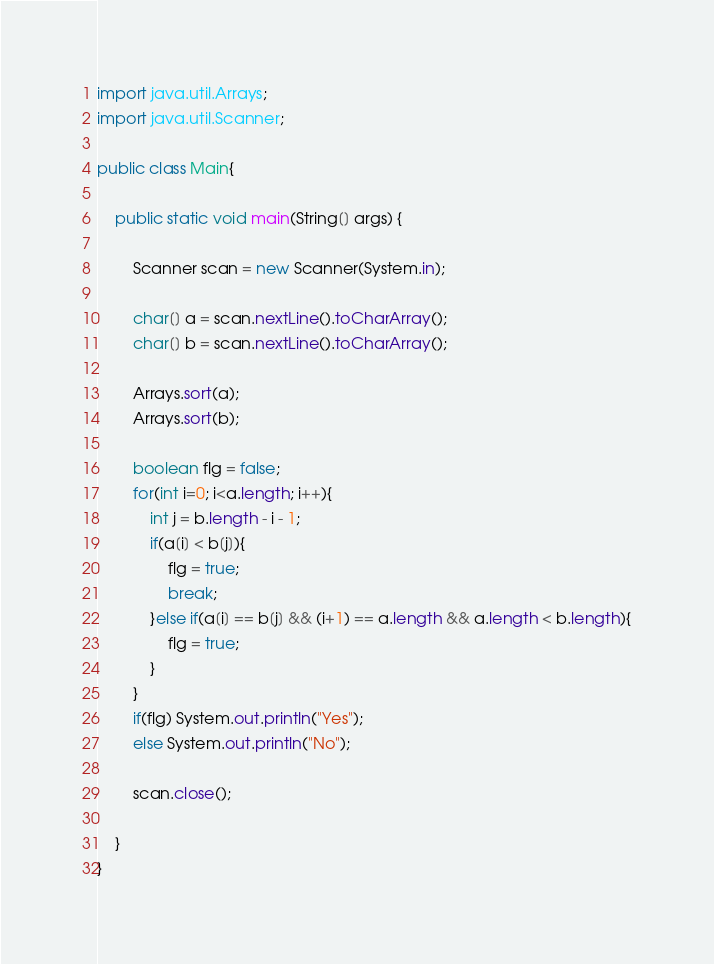Convert code to text. <code><loc_0><loc_0><loc_500><loc_500><_Java_>import java.util.Arrays;
import java.util.Scanner;

public class Main{

    public static void main(String[] args) {
        
        Scanner scan = new Scanner(System.in);
        
        char[] a = scan.nextLine().toCharArray();
        char[] b = scan.nextLine().toCharArray();

        Arrays.sort(a);
        Arrays.sort(b);

        boolean flg = false;
        for(int i=0; i<a.length; i++){
            int j = b.length - i - 1;
            if(a[i] < b[j]){
                flg = true;
                break;
            }else if(a[i] == b[j] && (i+1) == a.length && a.length < b.length){
                flg = true;
            }
        }
        if(flg) System.out.println("Yes");
        else System.out.println("No");

        scan.close();
        
    }
}</code> 